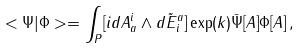<formula> <loc_0><loc_0><loc_500><loc_500>< \Psi | \Phi > = \int _ { P } [ i d A _ { a } ^ { i } \wedge d \tilde { E } ^ { a } _ { i } ] \exp ( k ) \bar { \Psi } [ A ] \Phi [ A ] \, ,</formula> 